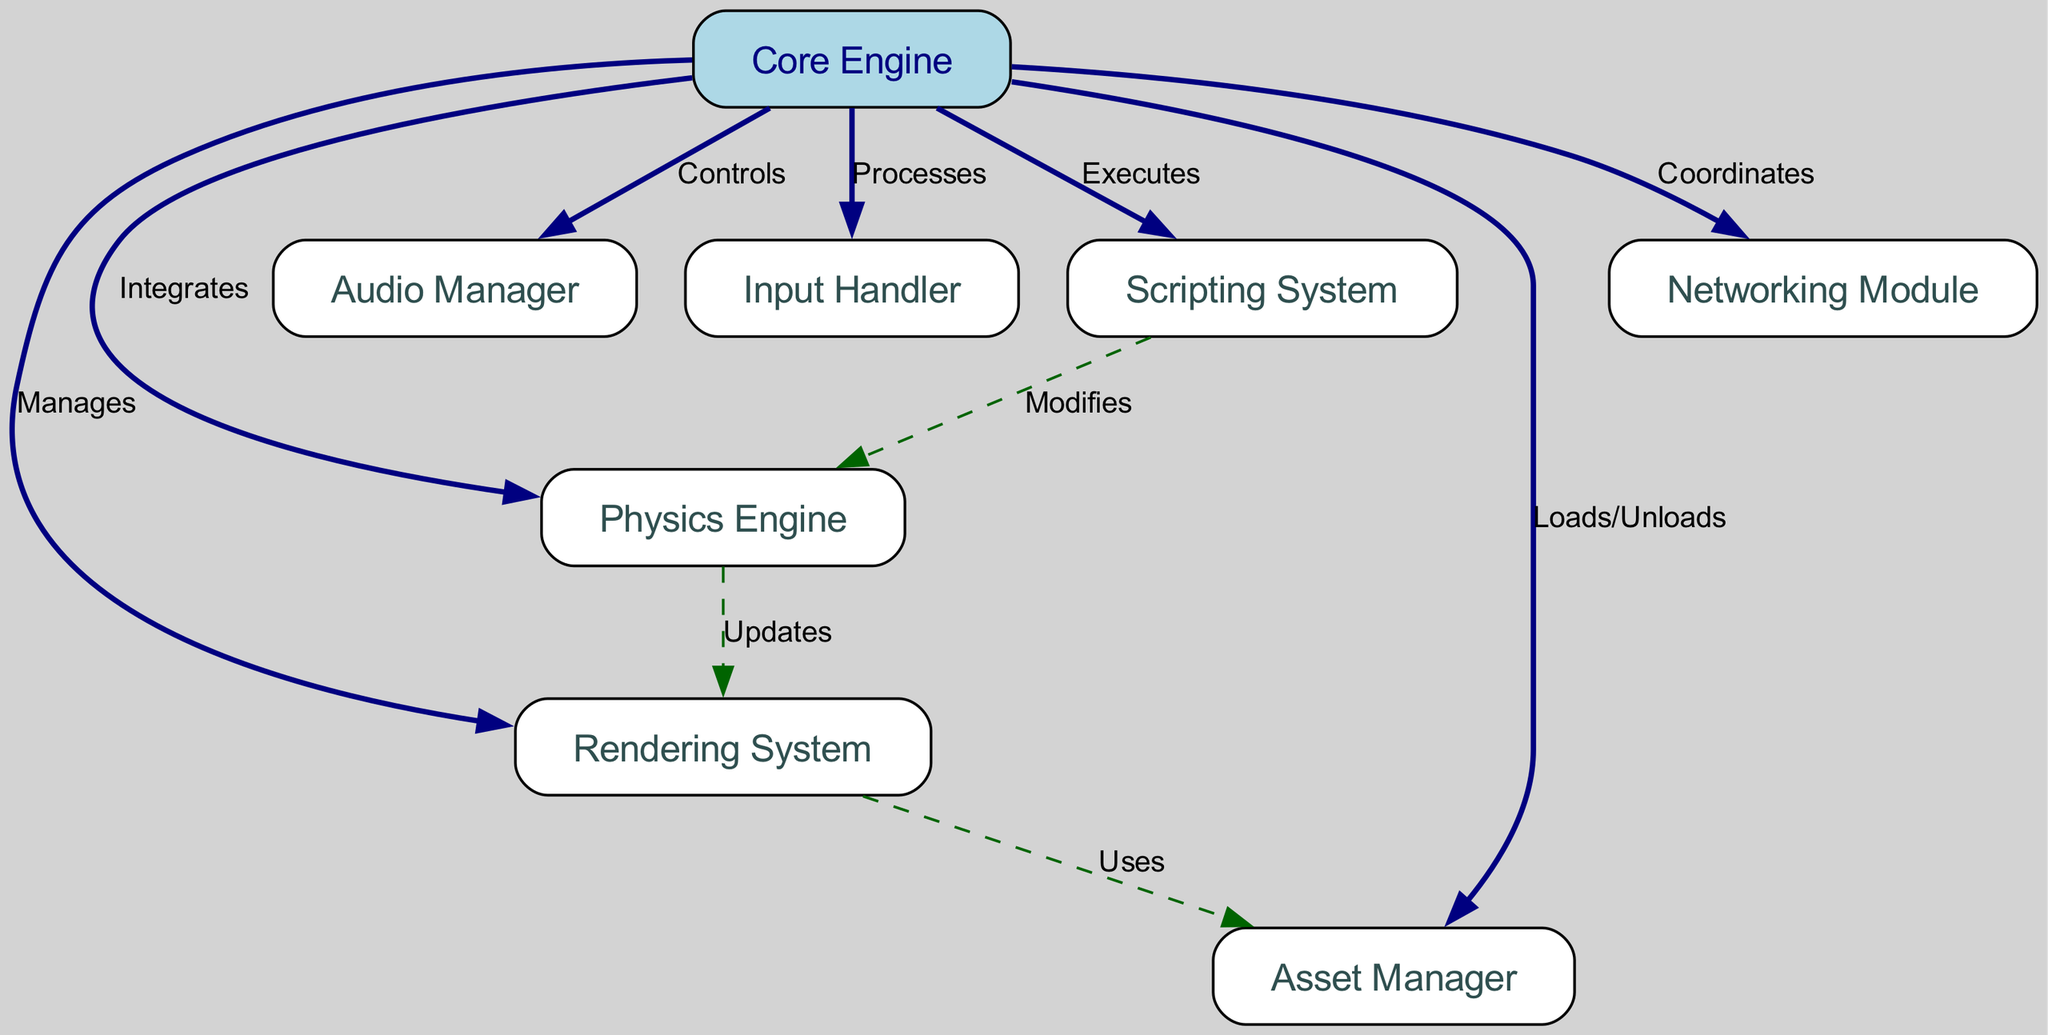what is the total number of nodes in the diagram? The diagram includes a list of nodes that are represented in the "nodes" section of the data. There are 8 distinct nodes specified: Core Engine, Rendering System, Physics Engine, Audio Manager, Input Handler, Scripting System, Asset Manager, and Networking Module. Counting them gives a total of 8 nodes.
Answer: 8 which component does the Core Engine manage? The Core Engine has a clear relationship with other components expressed through the edges. One of the edges states that the Core Engine "Manages" the Rendering System, indicating that it has a direct control relationship with this component.
Answer: Rendering System how many edges are there connecting the Core Engine to other modules? By examining the "edges" section of the data, we can count the number of edges that originate from the Core Engine. The Core Engine connects to seven other modules with the following relationships: manages, integrates, controls, processes, executes, loads/unloads, and coordinates. Therefore, there are 7 edges.
Answer: 7 which component updates the Rendering System? The diagram indicates that the Physics Engine "Updates" the Rendering System as mentioned in the edge labeled "Updates" from the Physics Engine to the Rendering System, demonstrating a direct relationship where the Physics Engine affects the Rendering System’s operations.
Answer: Physics Engine what action does the Scripting System perform on the Physics Engine? The data specifies that the Scripting System "Modifies" the Physics Engine, suggesting that it can change or influence how the Physics Engine operates. This is found in the edge from Scripting System to Physics Engine labeled "Modifies".
Answer: Modifies what is the main role of the Asset Manager in the diagram? The Asset Manager is involved with the Rendering System and Core Engine. It is stated that the Rendering System "Uses" the Asset Manager, and the Core Engine "Loads/Unloads" it. This indicates that its main role revolves around handling asset management for visuals used in rendering and the broader operations that the Core Engine oversees.
Answer: Asset management how does the core integrate with the networking module? The relationship between the Core Engine and the Networking Module is defined by the edge labeled "Coordinates", indicating that the Core Engine has a coordinating role over the Networking Module, likely managing its operations and ensuring it interacts properly with other components.
Answer: Coordinates what is the significance of the dashed edges in the diagram? In the diagram, dashed edges represent relationships that may not be as direct or controlling as the solid edges originating from the Core Engine. They indicate interactions that are more supportive or less central, providing a distinction between primary control and interactions in the architecture.
Answer: Interaction indicator 